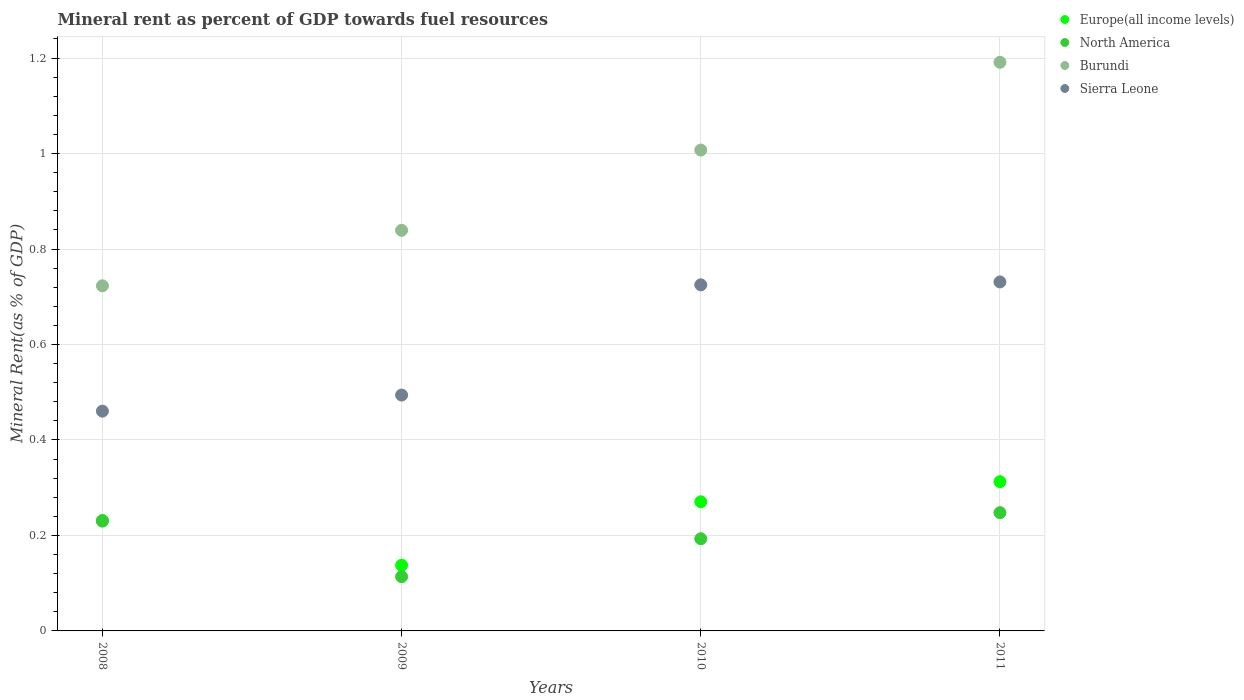What is the mineral rent in Europe(all income levels) in 2008?
Provide a succinct answer. 0.23. Across all years, what is the maximum mineral rent in Burundi?
Offer a terse response. 1.19. Across all years, what is the minimum mineral rent in Burundi?
Provide a short and direct response. 0.72. In which year was the mineral rent in Sierra Leone maximum?
Give a very brief answer. 2011. In which year was the mineral rent in Europe(all income levels) minimum?
Provide a succinct answer. 2009. What is the total mineral rent in Europe(all income levels) in the graph?
Ensure brevity in your answer.  0.95. What is the difference between the mineral rent in North America in 2009 and that in 2011?
Your answer should be compact. -0.13. What is the difference between the mineral rent in North America in 2011 and the mineral rent in Burundi in 2010?
Give a very brief answer. -0.76. What is the average mineral rent in Europe(all income levels) per year?
Provide a short and direct response. 0.24. In the year 2011, what is the difference between the mineral rent in North America and mineral rent in Burundi?
Give a very brief answer. -0.94. What is the ratio of the mineral rent in Sierra Leone in 2008 to that in 2009?
Keep it short and to the point. 0.93. What is the difference between the highest and the second highest mineral rent in Burundi?
Ensure brevity in your answer.  0.18. What is the difference between the highest and the lowest mineral rent in Burundi?
Keep it short and to the point. 0.47. In how many years, is the mineral rent in North America greater than the average mineral rent in North America taken over all years?
Provide a succinct answer. 2. Is the mineral rent in Sierra Leone strictly greater than the mineral rent in Burundi over the years?
Provide a succinct answer. No. How many years are there in the graph?
Your answer should be very brief. 4. Are the values on the major ticks of Y-axis written in scientific E-notation?
Provide a short and direct response. No. Does the graph contain any zero values?
Provide a succinct answer. No. Does the graph contain grids?
Ensure brevity in your answer.  Yes. What is the title of the graph?
Give a very brief answer. Mineral rent as percent of GDP towards fuel resources. What is the label or title of the X-axis?
Offer a terse response. Years. What is the label or title of the Y-axis?
Give a very brief answer. Mineral Rent(as % of GDP). What is the Mineral Rent(as % of GDP) of Europe(all income levels) in 2008?
Give a very brief answer. 0.23. What is the Mineral Rent(as % of GDP) in North America in 2008?
Ensure brevity in your answer.  0.23. What is the Mineral Rent(as % of GDP) of Burundi in 2008?
Your response must be concise. 0.72. What is the Mineral Rent(as % of GDP) of Sierra Leone in 2008?
Your answer should be compact. 0.46. What is the Mineral Rent(as % of GDP) in Europe(all income levels) in 2009?
Offer a very short reply. 0.14. What is the Mineral Rent(as % of GDP) in North America in 2009?
Keep it short and to the point. 0.11. What is the Mineral Rent(as % of GDP) of Burundi in 2009?
Your response must be concise. 0.84. What is the Mineral Rent(as % of GDP) in Sierra Leone in 2009?
Ensure brevity in your answer.  0.49. What is the Mineral Rent(as % of GDP) of Europe(all income levels) in 2010?
Provide a succinct answer. 0.27. What is the Mineral Rent(as % of GDP) in North America in 2010?
Provide a short and direct response. 0.19. What is the Mineral Rent(as % of GDP) of Burundi in 2010?
Offer a very short reply. 1.01. What is the Mineral Rent(as % of GDP) in Sierra Leone in 2010?
Offer a very short reply. 0.72. What is the Mineral Rent(as % of GDP) in Europe(all income levels) in 2011?
Offer a terse response. 0.31. What is the Mineral Rent(as % of GDP) of North America in 2011?
Offer a terse response. 0.25. What is the Mineral Rent(as % of GDP) of Burundi in 2011?
Give a very brief answer. 1.19. What is the Mineral Rent(as % of GDP) in Sierra Leone in 2011?
Make the answer very short. 0.73. Across all years, what is the maximum Mineral Rent(as % of GDP) of Europe(all income levels)?
Make the answer very short. 0.31. Across all years, what is the maximum Mineral Rent(as % of GDP) of North America?
Provide a succinct answer. 0.25. Across all years, what is the maximum Mineral Rent(as % of GDP) of Burundi?
Offer a terse response. 1.19. Across all years, what is the maximum Mineral Rent(as % of GDP) in Sierra Leone?
Give a very brief answer. 0.73. Across all years, what is the minimum Mineral Rent(as % of GDP) in Europe(all income levels)?
Offer a very short reply. 0.14. Across all years, what is the minimum Mineral Rent(as % of GDP) in North America?
Offer a very short reply. 0.11. Across all years, what is the minimum Mineral Rent(as % of GDP) of Burundi?
Offer a very short reply. 0.72. Across all years, what is the minimum Mineral Rent(as % of GDP) of Sierra Leone?
Ensure brevity in your answer.  0.46. What is the total Mineral Rent(as % of GDP) in Europe(all income levels) in the graph?
Your response must be concise. 0.95. What is the total Mineral Rent(as % of GDP) of North America in the graph?
Keep it short and to the point. 0.78. What is the total Mineral Rent(as % of GDP) in Burundi in the graph?
Your answer should be compact. 3.76. What is the total Mineral Rent(as % of GDP) in Sierra Leone in the graph?
Keep it short and to the point. 2.41. What is the difference between the Mineral Rent(as % of GDP) in Europe(all income levels) in 2008 and that in 2009?
Ensure brevity in your answer.  0.09. What is the difference between the Mineral Rent(as % of GDP) of North America in 2008 and that in 2009?
Your response must be concise. 0.12. What is the difference between the Mineral Rent(as % of GDP) in Burundi in 2008 and that in 2009?
Your answer should be compact. -0.12. What is the difference between the Mineral Rent(as % of GDP) in Sierra Leone in 2008 and that in 2009?
Your response must be concise. -0.03. What is the difference between the Mineral Rent(as % of GDP) in Europe(all income levels) in 2008 and that in 2010?
Offer a very short reply. -0.04. What is the difference between the Mineral Rent(as % of GDP) in North America in 2008 and that in 2010?
Make the answer very short. 0.04. What is the difference between the Mineral Rent(as % of GDP) of Burundi in 2008 and that in 2010?
Your answer should be compact. -0.28. What is the difference between the Mineral Rent(as % of GDP) of Sierra Leone in 2008 and that in 2010?
Offer a terse response. -0.26. What is the difference between the Mineral Rent(as % of GDP) of Europe(all income levels) in 2008 and that in 2011?
Ensure brevity in your answer.  -0.08. What is the difference between the Mineral Rent(as % of GDP) in North America in 2008 and that in 2011?
Your answer should be very brief. -0.02. What is the difference between the Mineral Rent(as % of GDP) in Burundi in 2008 and that in 2011?
Provide a short and direct response. -0.47. What is the difference between the Mineral Rent(as % of GDP) in Sierra Leone in 2008 and that in 2011?
Ensure brevity in your answer.  -0.27. What is the difference between the Mineral Rent(as % of GDP) of Europe(all income levels) in 2009 and that in 2010?
Provide a succinct answer. -0.13. What is the difference between the Mineral Rent(as % of GDP) in North America in 2009 and that in 2010?
Offer a very short reply. -0.08. What is the difference between the Mineral Rent(as % of GDP) of Burundi in 2009 and that in 2010?
Make the answer very short. -0.17. What is the difference between the Mineral Rent(as % of GDP) of Sierra Leone in 2009 and that in 2010?
Give a very brief answer. -0.23. What is the difference between the Mineral Rent(as % of GDP) in Europe(all income levels) in 2009 and that in 2011?
Keep it short and to the point. -0.17. What is the difference between the Mineral Rent(as % of GDP) in North America in 2009 and that in 2011?
Make the answer very short. -0.13. What is the difference between the Mineral Rent(as % of GDP) in Burundi in 2009 and that in 2011?
Your answer should be very brief. -0.35. What is the difference between the Mineral Rent(as % of GDP) in Sierra Leone in 2009 and that in 2011?
Your answer should be very brief. -0.24. What is the difference between the Mineral Rent(as % of GDP) of Europe(all income levels) in 2010 and that in 2011?
Ensure brevity in your answer.  -0.04. What is the difference between the Mineral Rent(as % of GDP) in North America in 2010 and that in 2011?
Provide a succinct answer. -0.05. What is the difference between the Mineral Rent(as % of GDP) in Burundi in 2010 and that in 2011?
Provide a short and direct response. -0.18. What is the difference between the Mineral Rent(as % of GDP) of Sierra Leone in 2010 and that in 2011?
Your response must be concise. -0.01. What is the difference between the Mineral Rent(as % of GDP) in Europe(all income levels) in 2008 and the Mineral Rent(as % of GDP) in North America in 2009?
Provide a succinct answer. 0.12. What is the difference between the Mineral Rent(as % of GDP) of Europe(all income levels) in 2008 and the Mineral Rent(as % of GDP) of Burundi in 2009?
Provide a succinct answer. -0.61. What is the difference between the Mineral Rent(as % of GDP) in Europe(all income levels) in 2008 and the Mineral Rent(as % of GDP) in Sierra Leone in 2009?
Your response must be concise. -0.26. What is the difference between the Mineral Rent(as % of GDP) of North America in 2008 and the Mineral Rent(as % of GDP) of Burundi in 2009?
Give a very brief answer. -0.61. What is the difference between the Mineral Rent(as % of GDP) of North America in 2008 and the Mineral Rent(as % of GDP) of Sierra Leone in 2009?
Your answer should be very brief. -0.26. What is the difference between the Mineral Rent(as % of GDP) in Burundi in 2008 and the Mineral Rent(as % of GDP) in Sierra Leone in 2009?
Give a very brief answer. 0.23. What is the difference between the Mineral Rent(as % of GDP) of Europe(all income levels) in 2008 and the Mineral Rent(as % of GDP) of North America in 2010?
Your answer should be very brief. 0.04. What is the difference between the Mineral Rent(as % of GDP) in Europe(all income levels) in 2008 and the Mineral Rent(as % of GDP) in Burundi in 2010?
Offer a terse response. -0.78. What is the difference between the Mineral Rent(as % of GDP) in Europe(all income levels) in 2008 and the Mineral Rent(as % of GDP) in Sierra Leone in 2010?
Ensure brevity in your answer.  -0.49. What is the difference between the Mineral Rent(as % of GDP) of North America in 2008 and the Mineral Rent(as % of GDP) of Burundi in 2010?
Make the answer very short. -0.78. What is the difference between the Mineral Rent(as % of GDP) of North America in 2008 and the Mineral Rent(as % of GDP) of Sierra Leone in 2010?
Give a very brief answer. -0.49. What is the difference between the Mineral Rent(as % of GDP) in Burundi in 2008 and the Mineral Rent(as % of GDP) in Sierra Leone in 2010?
Your answer should be compact. -0. What is the difference between the Mineral Rent(as % of GDP) in Europe(all income levels) in 2008 and the Mineral Rent(as % of GDP) in North America in 2011?
Provide a succinct answer. -0.02. What is the difference between the Mineral Rent(as % of GDP) of Europe(all income levels) in 2008 and the Mineral Rent(as % of GDP) of Burundi in 2011?
Give a very brief answer. -0.96. What is the difference between the Mineral Rent(as % of GDP) of Europe(all income levels) in 2008 and the Mineral Rent(as % of GDP) of Sierra Leone in 2011?
Offer a terse response. -0.5. What is the difference between the Mineral Rent(as % of GDP) in North America in 2008 and the Mineral Rent(as % of GDP) in Burundi in 2011?
Ensure brevity in your answer.  -0.96. What is the difference between the Mineral Rent(as % of GDP) in North America in 2008 and the Mineral Rent(as % of GDP) in Sierra Leone in 2011?
Provide a short and direct response. -0.5. What is the difference between the Mineral Rent(as % of GDP) in Burundi in 2008 and the Mineral Rent(as % of GDP) in Sierra Leone in 2011?
Make the answer very short. -0.01. What is the difference between the Mineral Rent(as % of GDP) of Europe(all income levels) in 2009 and the Mineral Rent(as % of GDP) of North America in 2010?
Give a very brief answer. -0.06. What is the difference between the Mineral Rent(as % of GDP) in Europe(all income levels) in 2009 and the Mineral Rent(as % of GDP) in Burundi in 2010?
Make the answer very short. -0.87. What is the difference between the Mineral Rent(as % of GDP) of Europe(all income levels) in 2009 and the Mineral Rent(as % of GDP) of Sierra Leone in 2010?
Provide a short and direct response. -0.59. What is the difference between the Mineral Rent(as % of GDP) of North America in 2009 and the Mineral Rent(as % of GDP) of Burundi in 2010?
Keep it short and to the point. -0.89. What is the difference between the Mineral Rent(as % of GDP) of North America in 2009 and the Mineral Rent(as % of GDP) of Sierra Leone in 2010?
Ensure brevity in your answer.  -0.61. What is the difference between the Mineral Rent(as % of GDP) in Burundi in 2009 and the Mineral Rent(as % of GDP) in Sierra Leone in 2010?
Ensure brevity in your answer.  0.11. What is the difference between the Mineral Rent(as % of GDP) of Europe(all income levels) in 2009 and the Mineral Rent(as % of GDP) of North America in 2011?
Your answer should be very brief. -0.11. What is the difference between the Mineral Rent(as % of GDP) of Europe(all income levels) in 2009 and the Mineral Rent(as % of GDP) of Burundi in 2011?
Your response must be concise. -1.05. What is the difference between the Mineral Rent(as % of GDP) in Europe(all income levels) in 2009 and the Mineral Rent(as % of GDP) in Sierra Leone in 2011?
Make the answer very short. -0.59. What is the difference between the Mineral Rent(as % of GDP) in North America in 2009 and the Mineral Rent(as % of GDP) in Burundi in 2011?
Ensure brevity in your answer.  -1.08. What is the difference between the Mineral Rent(as % of GDP) in North America in 2009 and the Mineral Rent(as % of GDP) in Sierra Leone in 2011?
Your answer should be compact. -0.62. What is the difference between the Mineral Rent(as % of GDP) of Burundi in 2009 and the Mineral Rent(as % of GDP) of Sierra Leone in 2011?
Offer a terse response. 0.11. What is the difference between the Mineral Rent(as % of GDP) in Europe(all income levels) in 2010 and the Mineral Rent(as % of GDP) in North America in 2011?
Provide a succinct answer. 0.02. What is the difference between the Mineral Rent(as % of GDP) of Europe(all income levels) in 2010 and the Mineral Rent(as % of GDP) of Burundi in 2011?
Your answer should be compact. -0.92. What is the difference between the Mineral Rent(as % of GDP) of Europe(all income levels) in 2010 and the Mineral Rent(as % of GDP) of Sierra Leone in 2011?
Ensure brevity in your answer.  -0.46. What is the difference between the Mineral Rent(as % of GDP) in North America in 2010 and the Mineral Rent(as % of GDP) in Burundi in 2011?
Offer a very short reply. -1. What is the difference between the Mineral Rent(as % of GDP) in North America in 2010 and the Mineral Rent(as % of GDP) in Sierra Leone in 2011?
Your answer should be compact. -0.54. What is the difference between the Mineral Rent(as % of GDP) of Burundi in 2010 and the Mineral Rent(as % of GDP) of Sierra Leone in 2011?
Make the answer very short. 0.28. What is the average Mineral Rent(as % of GDP) of Europe(all income levels) per year?
Provide a short and direct response. 0.24. What is the average Mineral Rent(as % of GDP) in North America per year?
Offer a very short reply. 0.2. What is the average Mineral Rent(as % of GDP) of Burundi per year?
Your answer should be compact. 0.94. What is the average Mineral Rent(as % of GDP) in Sierra Leone per year?
Provide a short and direct response. 0.6. In the year 2008, what is the difference between the Mineral Rent(as % of GDP) in Europe(all income levels) and Mineral Rent(as % of GDP) in North America?
Provide a succinct answer. 0. In the year 2008, what is the difference between the Mineral Rent(as % of GDP) in Europe(all income levels) and Mineral Rent(as % of GDP) in Burundi?
Provide a short and direct response. -0.49. In the year 2008, what is the difference between the Mineral Rent(as % of GDP) of Europe(all income levels) and Mineral Rent(as % of GDP) of Sierra Leone?
Give a very brief answer. -0.23. In the year 2008, what is the difference between the Mineral Rent(as % of GDP) of North America and Mineral Rent(as % of GDP) of Burundi?
Give a very brief answer. -0.49. In the year 2008, what is the difference between the Mineral Rent(as % of GDP) in North America and Mineral Rent(as % of GDP) in Sierra Leone?
Ensure brevity in your answer.  -0.23. In the year 2008, what is the difference between the Mineral Rent(as % of GDP) in Burundi and Mineral Rent(as % of GDP) in Sierra Leone?
Your response must be concise. 0.26. In the year 2009, what is the difference between the Mineral Rent(as % of GDP) in Europe(all income levels) and Mineral Rent(as % of GDP) in North America?
Provide a succinct answer. 0.02. In the year 2009, what is the difference between the Mineral Rent(as % of GDP) in Europe(all income levels) and Mineral Rent(as % of GDP) in Burundi?
Your answer should be very brief. -0.7. In the year 2009, what is the difference between the Mineral Rent(as % of GDP) in Europe(all income levels) and Mineral Rent(as % of GDP) in Sierra Leone?
Offer a terse response. -0.36. In the year 2009, what is the difference between the Mineral Rent(as % of GDP) of North America and Mineral Rent(as % of GDP) of Burundi?
Offer a very short reply. -0.73. In the year 2009, what is the difference between the Mineral Rent(as % of GDP) of North America and Mineral Rent(as % of GDP) of Sierra Leone?
Keep it short and to the point. -0.38. In the year 2009, what is the difference between the Mineral Rent(as % of GDP) of Burundi and Mineral Rent(as % of GDP) of Sierra Leone?
Keep it short and to the point. 0.35. In the year 2010, what is the difference between the Mineral Rent(as % of GDP) of Europe(all income levels) and Mineral Rent(as % of GDP) of North America?
Ensure brevity in your answer.  0.08. In the year 2010, what is the difference between the Mineral Rent(as % of GDP) of Europe(all income levels) and Mineral Rent(as % of GDP) of Burundi?
Your response must be concise. -0.74. In the year 2010, what is the difference between the Mineral Rent(as % of GDP) in Europe(all income levels) and Mineral Rent(as % of GDP) in Sierra Leone?
Make the answer very short. -0.45. In the year 2010, what is the difference between the Mineral Rent(as % of GDP) in North America and Mineral Rent(as % of GDP) in Burundi?
Offer a very short reply. -0.81. In the year 2010, what is the difference between the Mineral Rent(as % of GDP) of North America and Mineral Rent(as % of GDP) of Sierra Leone?
Provide a succinct answer. -0.53. In the year 2010, what is the difference between the Mineral Rent(as % of GDP) in Burundi and Mineral Rent(as % of GDP) in Sierra Leone?
Your answer should be very brief. 0.28. In the year 2011, what is the difference between the Mineral Rent(as % of GDP) in Europe(all income levels) and Mineral Rent(as % of GDP) in North America?
Your answer should be very brief. 0.06. In the year 2011, what is the difference between the Mineral Rent(as % of GDP) of Europe(all income levels) and Mineral Rent(as % of GDP) of Burundi?
Offer a terse response. -0.88. In the year 2011, what is the difference between the Mineral Rent(as % of GDP) of Europe(all income levels) and Mineral Rent(as % of GDP) of Sierra Leone?
Provide a succinct answer. -0.42. In the year 2011, what is the difference between the Mineral Rent(as % of GDP) in North America and Mineral Rent(as % of GDP) in Burundi?
Ensure brevity in your answer.  -0.94. In the year 2011, what is the difference between the Mineral Rent(as % of GDP) in North America and Mineral Rent(as % of GDP) in Sierra Leone?
Give a very brief answer. -0.48. In the year 2011, what is the difference between the Mineral Rent(as % of GDP) in Burundi and Mineral Rent(as % of GDP) in Sierra Leone?
Provide a short and direct response. 0.46. What is the ratio of the Mineral Rent(as % of GDP) of Europe(all income levels) in 2008 to that in 2009?
Keep it short and to the point. 1.68. What is the ratio of the Mineral Rent(as % of GDP) in North America in 2008 to that in 2009?
Ensure brevity in your answer.  2.02. What is the ratio of the Mineral Rent(as % of GDP) in Burundi in 2008 to that in 2009?
Offer a terse response. 0.86. What is the ratio of the Mineral Rent(as % of GDP) in Sierra Leone in 2008 to that in 2009?
Provide a succinct answer. 0.93. What is the ratio of the Mineral Rent(as % of GDP) in Europe(all income levels) in 2008 to that in 2010?
Your answer should be compact. 0.86. What is the ratio of the Mineral Rent(as % of GDP) in North America in 2008 to that in 2010?
Provide a short and direct response. 1.19. What is the ratio of the Mineral Rent(as % of GDP) of Burundi in 2008 to that in 2010?
Keep it short and to the point. 0.72. What is the ratio of the Mineral Rent(as % of GDP) of Sierra Leone in 2008 to that in 2010?
Give a very brief answer. 0.64. What is the ratio of the Mineral Rent(as % of GDP) of Europe(all income levels) in 2008 to that in 2011?
Give a very brief answer. 0.74. What is the ratio of the Mineral Rent(as % of GDP) in North America in 2008 to that in 2011?
Your answer should be very brief. 0.93. What is the ratio of the Mineral Rent(as % of GDP) in Burundi in 2008 to that in 2011?
Your response must be concise. 0.61. What is the ratio of the Mineral Rent(as % of GDP) of Sierra Leone in 2008 to that in 2011?
Give a very brief answer. 0.63. What is the ratio of the Mineral Rent(as % of GDP) in Europe(all income levels) in 2009 to that in 2010?
Make the answer very short. 0.51. What is the ratio of the Mineral Rent(as % of GDP) of North America in 2009 to that in 2010?
Keep it short and to the point. 0.59. What is the ratio of the Mineral Rent(as % of GDP) in Burundi in 2009 to that in 2010?
Give a very brief answer. 0.83. What is the ratio of the Mineral Rent(as % of GDP) in Sierra Leone in 2009 to that in 2010?
Offer a terse response. 0.68. What is the ratio of the Mineral Rent(as % of GDP) in Europe(all income levels) in 2009 to that in 2011?
Provide a short and direct response. 0.44. What is the ratio of the Mineral Rent(as % of GDP) of North America in 2009 to that in 2011?
Give a very brief answer. 0.46. What is the ratio of the Mineral Rent(as % of GDP) of Burundi in 2009 to that in 2011?
Ensure brevity in your answer.  0.7. What is the ratio of the Mineral Rent(as % of GDP) in Sierra Leone in 2009 to that in 2011?
Your answer should be very brief. 0.68. What is the ratio of the Mineral Rent(as % of GDP) of Europe(all income levels) in 2010 to that in 2011?
Make the answer very short. 0.87. What is the ratio of the Mineral Rent(as % of GDP) of North America in 2010 to that in 2011?
Ensure brevity in your answer.  0.78. What is the ratio of the Mineral Rent(as % of GDP) of Burundi in 2010 to that in 2011?
Keep it short and to the point. 0.85. What is the ratio of the Mineral Rent(as % of GDP) in Sierra Leone in 2010 to that in 2011?
Provide a short and direct response. 0.99. What is the difference between the highest and the second highest Mineral Rent(as % of GDP) in Europe(all income levels)?
Provide a short and direct response. 0.04. What is the difference between the highest and the second highest Mineral Rent(as % of GDP) in North America?
Give a very brief answer. 0.02. What is the difference between the highest and the second highest Mineral Rent(as % of GDP) in Burundi?
Your response must be concise. 0.18. What is the difference between the highest and the second highest Mineral Rent(as % of GDP) of Sierra Leone?
Ensure brevity in your answer.  0.01. What is the difference between the highest and the lowest Mineral Rent(as % of GDP) in Europe(all income levels)?
Your answer should be compact. 0.17. What is the difference between the highest and the lowest Mineral Rent(as % of GDP) of North America?
Offer a terse response. 0.13. What is the difference between the highest and the lowest Mineral Rent(as % of GDP) of Burundi?
Ensure brevity in your answer.  0.47. What is the difference between the highest and the lowest Mineral Rent(as % of GDP) in Sierra Leone?
Your answer should be very brief. 0.27. 